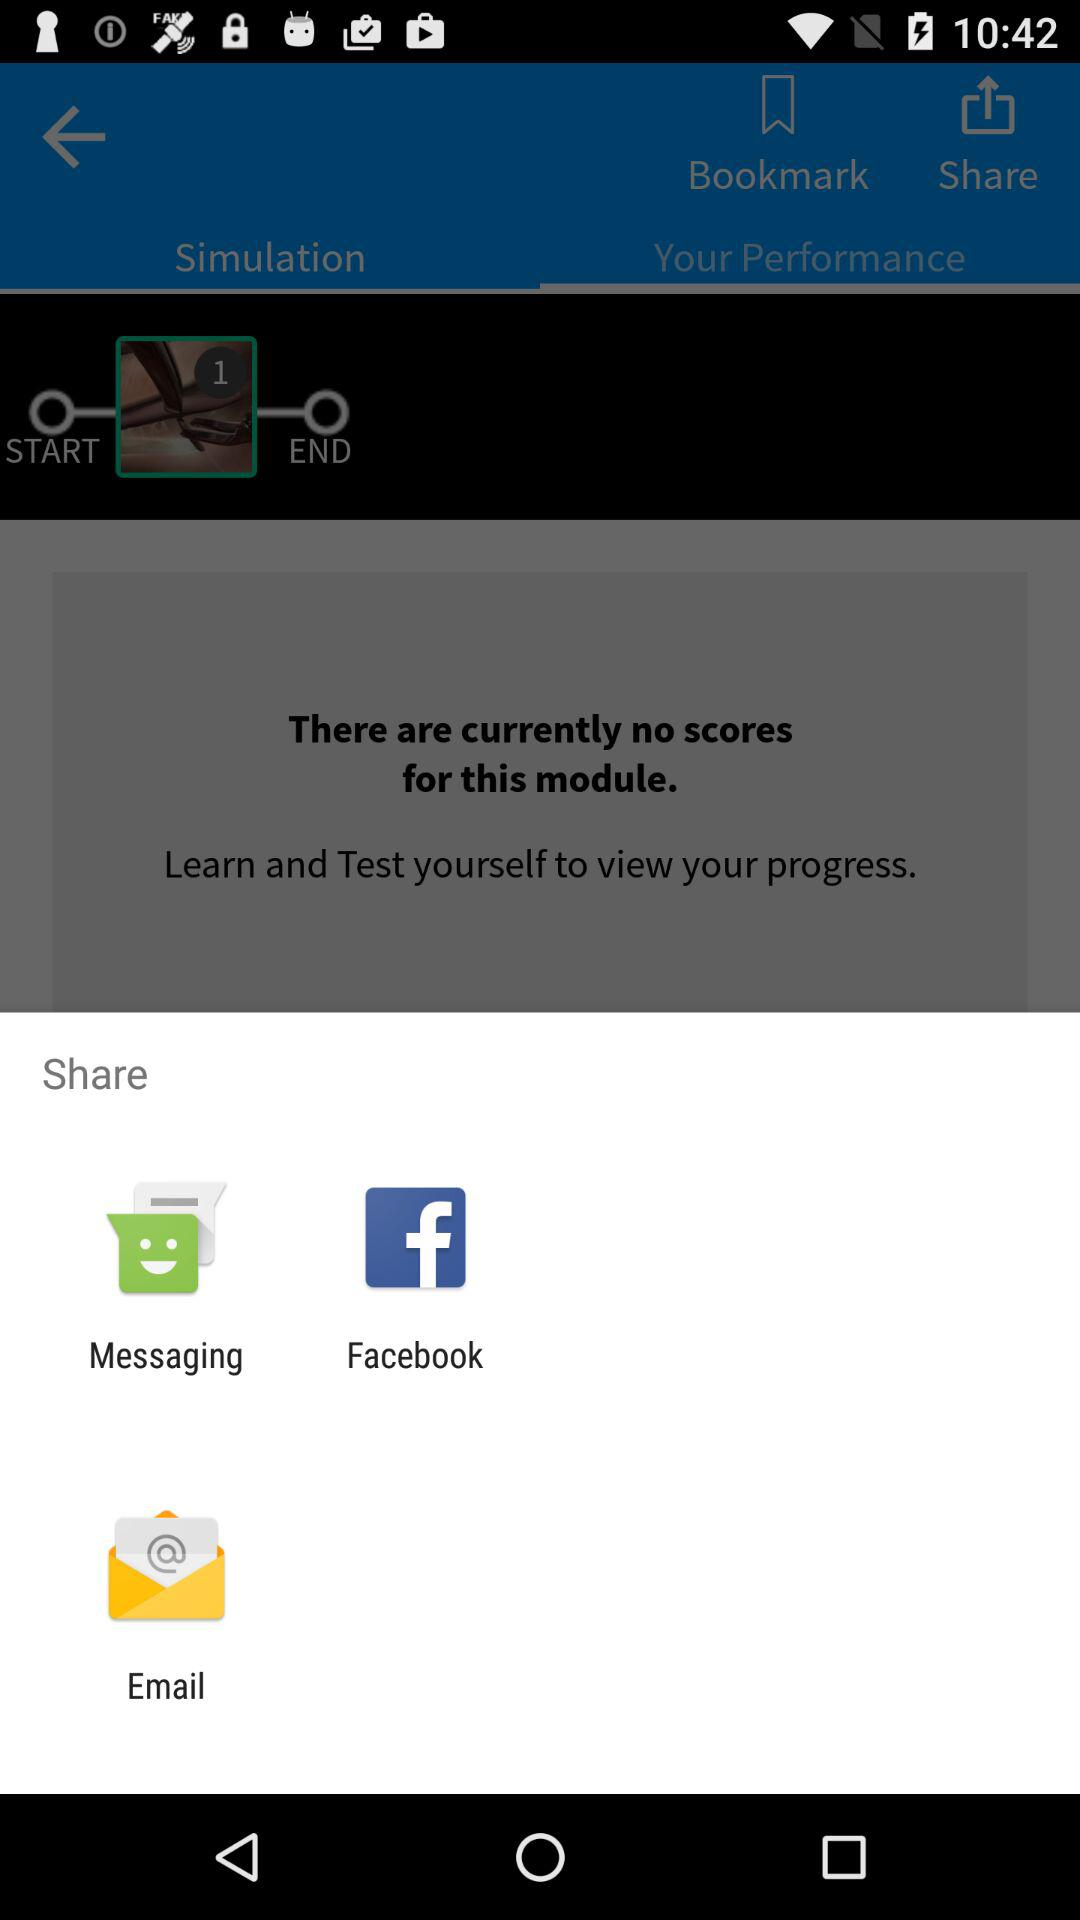Through what app can I share? You can share it through "Messaging", "Facebook", and "Email". 